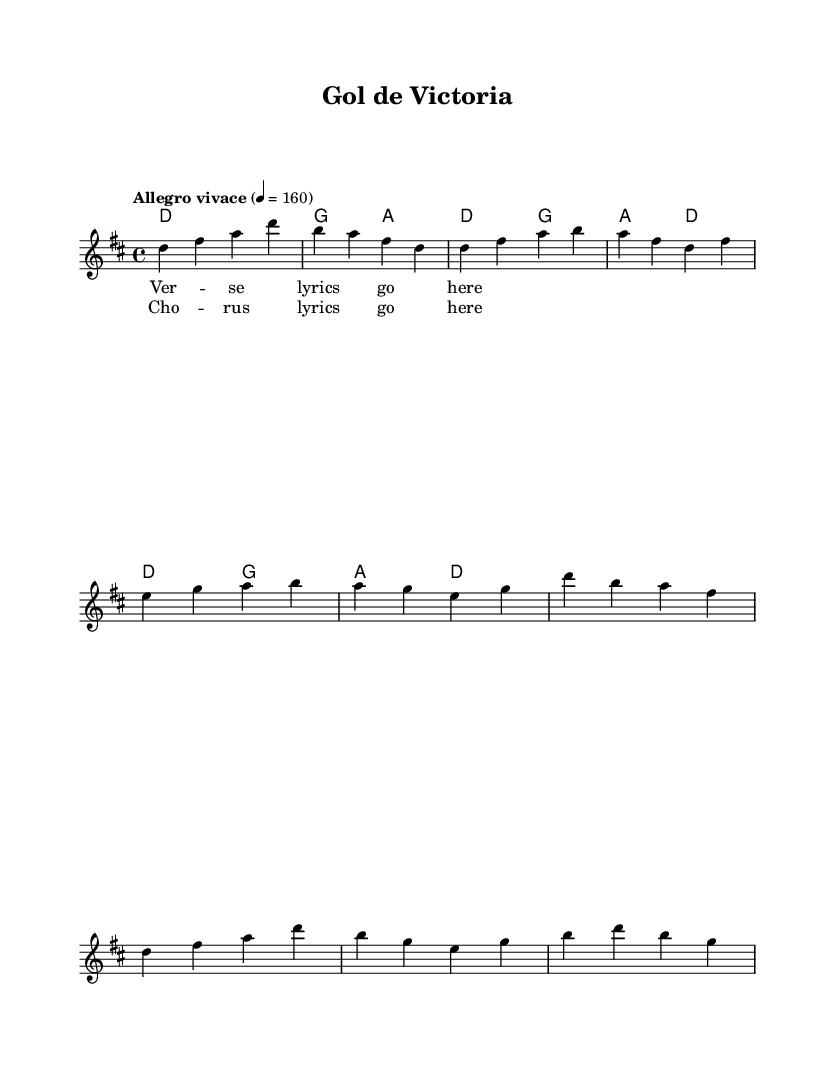What is the key signature of this music? The key signature is indicated at the beginning of the score. In this case, the music has two sharps, which corresponds to D major.
Answer: D major What is the time signature of this music? The time signature is found at the beginning of the score, showing the organization of beats. Here, it is displayed as 4 over 4, which means there are four beats in each measure.
Answer: 4/4 What is the tempo marking for this music? The tempo marking is provided in Italian and can be found at the start of the score, indicating how fast the music should be played. In this case, it is marked "Allegro vivace," which means lively and fast.
Answer: Allegro vivace How many measures are there in the verse? To determine the number of measures in the verse, we count the sections in the melody part labeled as "Verse." There are four measures listed there.
Answer: 4 What are the starting notes of the chorus? The starting notes can be found in the melody part labeled as "Chorus." The first measure of the chorus begins with the notes D, B, A, and F#.
Answer: D, B, A, F# What is the harmonic structure in the introduction? The harmonic structure consists of the chords specified in the harmonies section. In the intro, the chords are D major followed by G major and A major in the next measure.
Answer: D, G, A Which style does this music embody? The music embodies Latin dance music, as suggested in the title and energetic rhythms that are characteristic of the genre.
Answer: Latin dance 